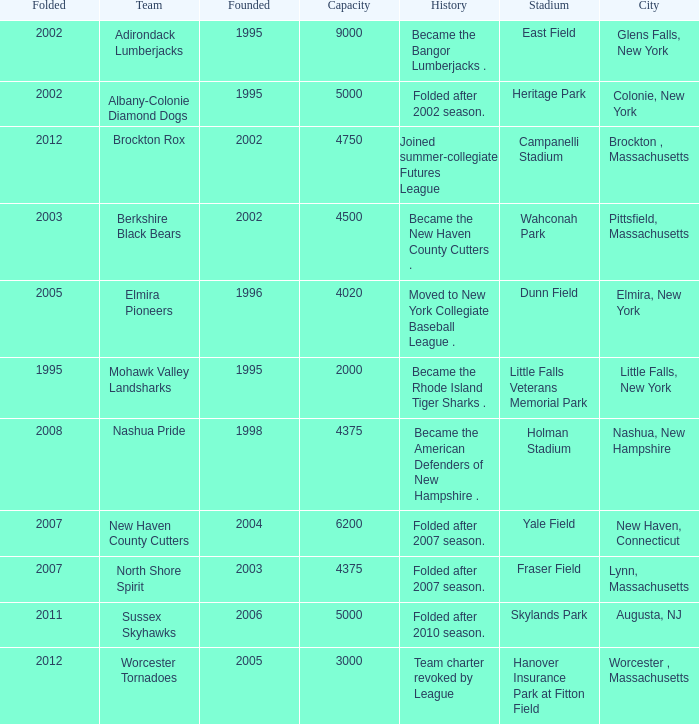What is the maximum folded value of the team whose stadium is Fraser Field? 2007.0. 